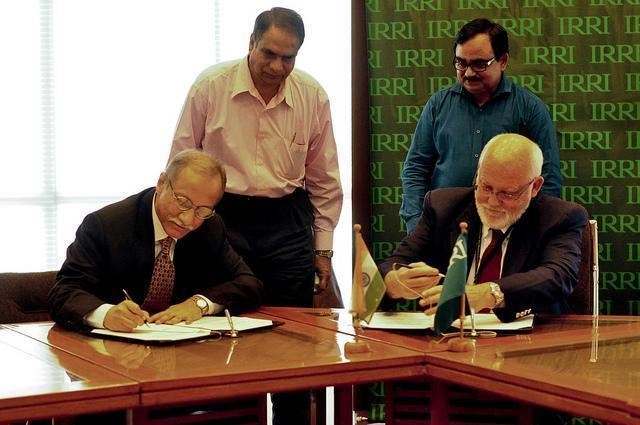How many men are sitting down?
Give a very brief answer. 2. How many men are wearing  glasses?
Give a very brief answer. 3. How many people are in the picture?
Give a very brief answer. 4. How many chairs are visible?
Give a very brief answer. 2. How many bikes are there?
Give a very brief answer. 0. 